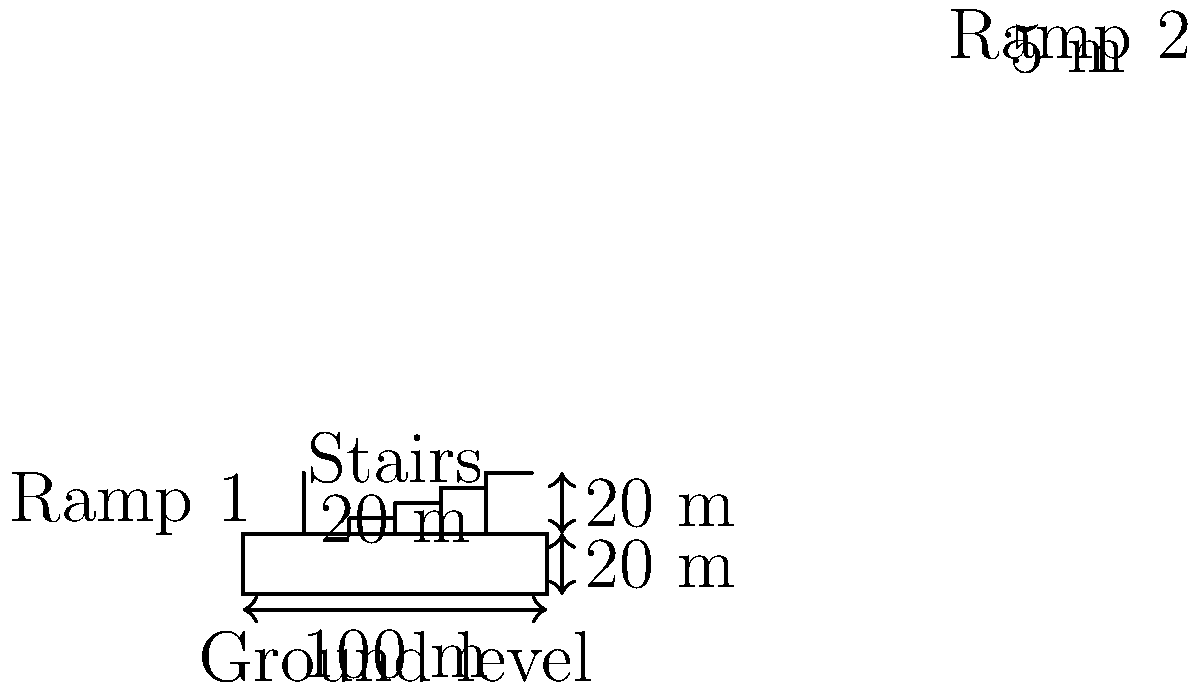As a railway project manager, you're tasked with designing an accessible pedestrian overpass connecting two platforms. The overpass needs to be 100 meters long and 20 meters above the ground level. You decide to include both stairs and ramps for accessibility. If the maximum allowed slope for the ramps is 1:12 (rise:run), what is the minimum horizontal distance required for each ramp to reach the overpass level? Let's approach this step-by-step:

1. Understand the given information:
   - Overpass height: 20 meters
   - Maximum allowed slope for ramps: 1:12 (rise:run)

2. Convert the slope ratio to a decimal:
   Slope = rise / run = 1 / 12 ≈ 0.0833

3. Use the slope formula to find the required horizontal distance:
   Slope = rise / run
   0.0833 = 20 / run

4. Solve for the run (horizontal distance):
   run = 20 / 0.0833 = 240 meters

5. Since there are two ramps (one on each side), we can divide this distance by 2:
   Distance for each ramp = 240 / 2 = 120 meters

Therefore, each ramp needs a minimum horizontal distance of 120 meters to reach the overpass level while maintaining the maximum allowed slope of 1:12.
Answer: 120 meters 